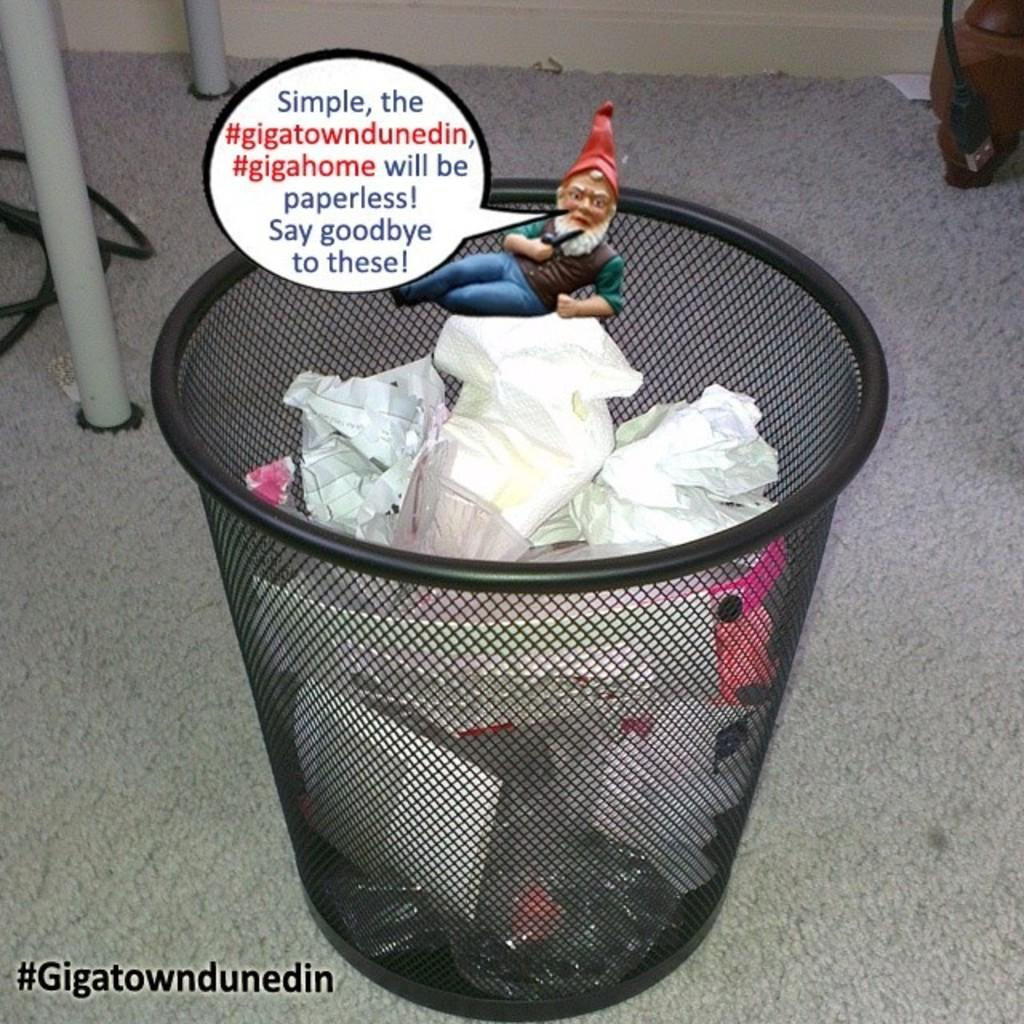<image>
Render a clear and concise summary of the photo. A full trash can with an elf above it with a hashtag of Gigatowndunedin. 